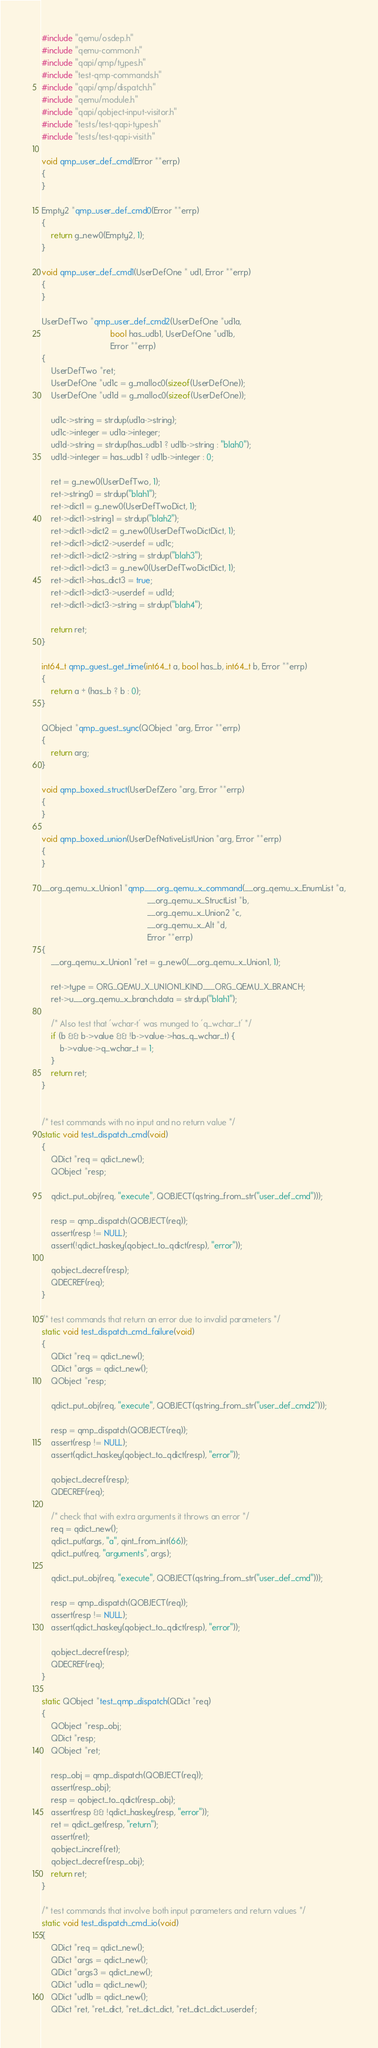Convert code to text. <code><loc_0><loc_0><loc_500><loc_500><_C_>#include "qemu/osdep.h"
#include "qemu-common.h"
#include "qapi/qmp/types.h"
#include "test-qmp-commands.h"
#include "qapi/qmp/dispatch.h"
#include "qemu/module.h"
#include "qapi/qobject-input-visitor.h"
#include "tests/test-qapi-types.h"
#include "tests/test-qapi-visit.h"

void qmp_user_def_cmd(Error **errp)
{
}

Empty2 *qmp_user_def_cmd0(Error **errp)
{
    return g_new0(Empty2, 1);
}

void qmp_user_def_cmd1(UserDefOne * ud1, Error **errp)
{
}

UserDefTwo *qmp_user_def_cmd2(UserDefOne *ud1a,
                              bool has_udb1, UserDefOne *ud1b,
                              Error **errp)
{
    UserDefTwo *ret;
    UserDefOne *ud1c = g_malloc0(sizeof(UserDefOne));
    UserDefOne *ud1d = g_malloc0(sizeof(UserDefOne));

    ud1c->string = strdup(ud1a->string);
    ud1c->integer = ud1a->integer;
    ud1d->string = strdup(has_udb1 ? ud1b->string : "blah0");
    ud1d->integer = has_udb1 ? ud1b->integer : 0;

    ret = g_new0(UserDefTwo, 1);
    ret->string0 = strdup("blah1");
    ret->dict1 = g_new0(UserDefTwoDict, 1);
    ret->dict1->string1 = strdup("blah2");
    ret->dict1->dict2 = g_new0(UserDefTwoDictDict, 1);
    ret->dict1->dict2->userdef = ud1c;
    ret->dict1->dict2->string = strdup("blah3");
    ret->dict1->dict3 = g_new0(UserDefTwoDictDict, 1);
    ret->dict1->has_dict3 = true;
    ret->dict1->dict3->userdef = ud1d;
    ret->dict1->dict3->string = strdup("blah4");

    return ret;
}

int64_t qmp_guest_get_time(int64_t a, bool has_b, int64_t b, Error **errp)
{
    return a + (has_b ? b : 0);
}

QObject *qmp_guest_sync(QObject *arg, Error **errp)
{
    return arg;
}

void qmp_boxed_struct(UserDefZero *arg, Error **errp)
{
}

void qmp_boxed_union(UserDefNativeListUnion *arg, Error **errp)
{
}

__org_qemu_x_Union1 *qmp___org_qemu_x_command(__org_qemu_x_EnumList *a,
                                              __org_qemu_x_StructList *b,
                                              __org_qemu_x_Union2 *c,
                                              __org_qemu_x_Alt *d,
                                              Error **errp)
{
    __org_qemu_x_Union1 *ret = g_new0(__org_qemu_x_Union1, 1);

    ret->type = ORG_QEMU_X_UNION1_KIND___ORG_QEMU_X_BRANCH;
    ret->u.__org_qemu_x_branch.data = strdup("blah1");

    /* Also test that 'wchar-t' was munged to 'q_wchar_t' */
    if (b && b->value && !b->value->has_q_wchar_t) {
        b->value->q_wchar_t = 1;
    }
    return ret;
}


/* test commands with no input and no return value */
static void test_dispatch_cmd(void)
{
    QDict *req = qdict_new();
    QObject *resp;

    qdict_put_obj(req, "execute", QOBJECT(qstring_from_str("user_def_cmd")));

    resp = qmp_dispatch(QOBJECT(req));
    assert(resp != NULL);
    assert(!qdict_haskey(qobject_to_qdict(resp), "error"));

    qobject_decref(resp);
    QDECREF(req);
}

/* test commands that return an error due to invalid parameters */
static void test_dispatch_cmd_failure(void)
{
    QDict *req = qdict_new();
    QDict *args = qdict_new();
    QObject *resp;

    qdict_put_obj(req, "execute", QOBJECT(qstring_from_str("user_def_cmd2")));

    resp = qmp_dispatch(QOBJECT(req));
    assert(resp != NULL);
    assert(qdict_haskey(qobject_to_qdict(resp), "error"));

    qobject_decref(resp);
    QDECREF(req);

    /* check that with extra arguments it throws an error */
    req = qdict_new();
    qdict_put(args, "a", qint_from_int(66));
    qdict_put(req, "arguments", args);

    qdict_put_obj(req, "execute", QOBJECT(qstring_from_str("user_def_cmd")));

    resp = qmp_dispatch(QOBJECT(req));
    assert(resp != NULL);
    assert(qdict_haskey(qobject_to_qdict(resp), "error"));

    qobject_decref(resp);
    QDECREF(req);
}

static QObject *test_qmp_dispatch(QDict *req)
{
    QObject *resp_obj;
    QDict *resp;
    QObject *ret;

    resp_obj = qmp_dispatch(QOBJECT(req));
    assert(resp_obj);
    resp = qobject_to_qdict(resp_obj);
    assert(resp && !qdict_haskey(resp, "error"));
    ret = qdict_get(resp, "return");
    assert(ret);
    qobject_incref(ret);
    qobject_decref(resp_obj);
    return ret;
}

/* test commands that involve both input parameters and return values */
static void test_dispatch_cmd_io(void)
{
    QDict *req = qdict_new();
    QDict *args = qdict_new();
    QDict *args3 = qdict_new();
    QDict *ud1a = qdict_new();
    QDict *ud1b = qdict_new();
    QDict *ret, *ret_dict, *ret_dict_dict, *ret_dict_dict_userdef;</code> 